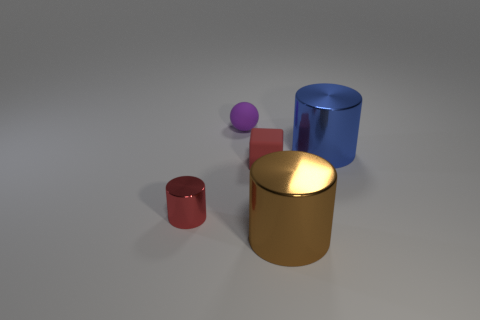How many brown things are either small matte objects or tiny cylinders?
Keep it short and to the point. 0. The large object that is in front of the big shiny cylinder to the right of the big brown object is what color?
Your answer should be very brief. Brown. There is another object that is the same color as the tiny metallic object; what is it made of?
Keep it short and to the point. Rubber. There is a big thing behind the big brown metallic object; what color is it?
Offer a very short reply. Blue. There is a red object to the left of the red block; does it have the same size as the tiny matte block?
Give a very brief answer. Yes. What is the size of the thing that is the same color as the matte cube?
Provide a succinct answer. Small. Are there any brown objects that have the same size as the purple rubber thing?
Provide a succinct answer. No. There is a large metal object to the right of the brown shiny object; does it have the same color as the tiny rubber thing that is behind the blue shiny cylinder?
Ensure brevity in your answer.  No. Is there a rubber cube of the same color as the ball?
Your answer should be very brief. No. How many other objects are there of the same shape as the blue metallic thing?
Provide a succinct answer. 2. 